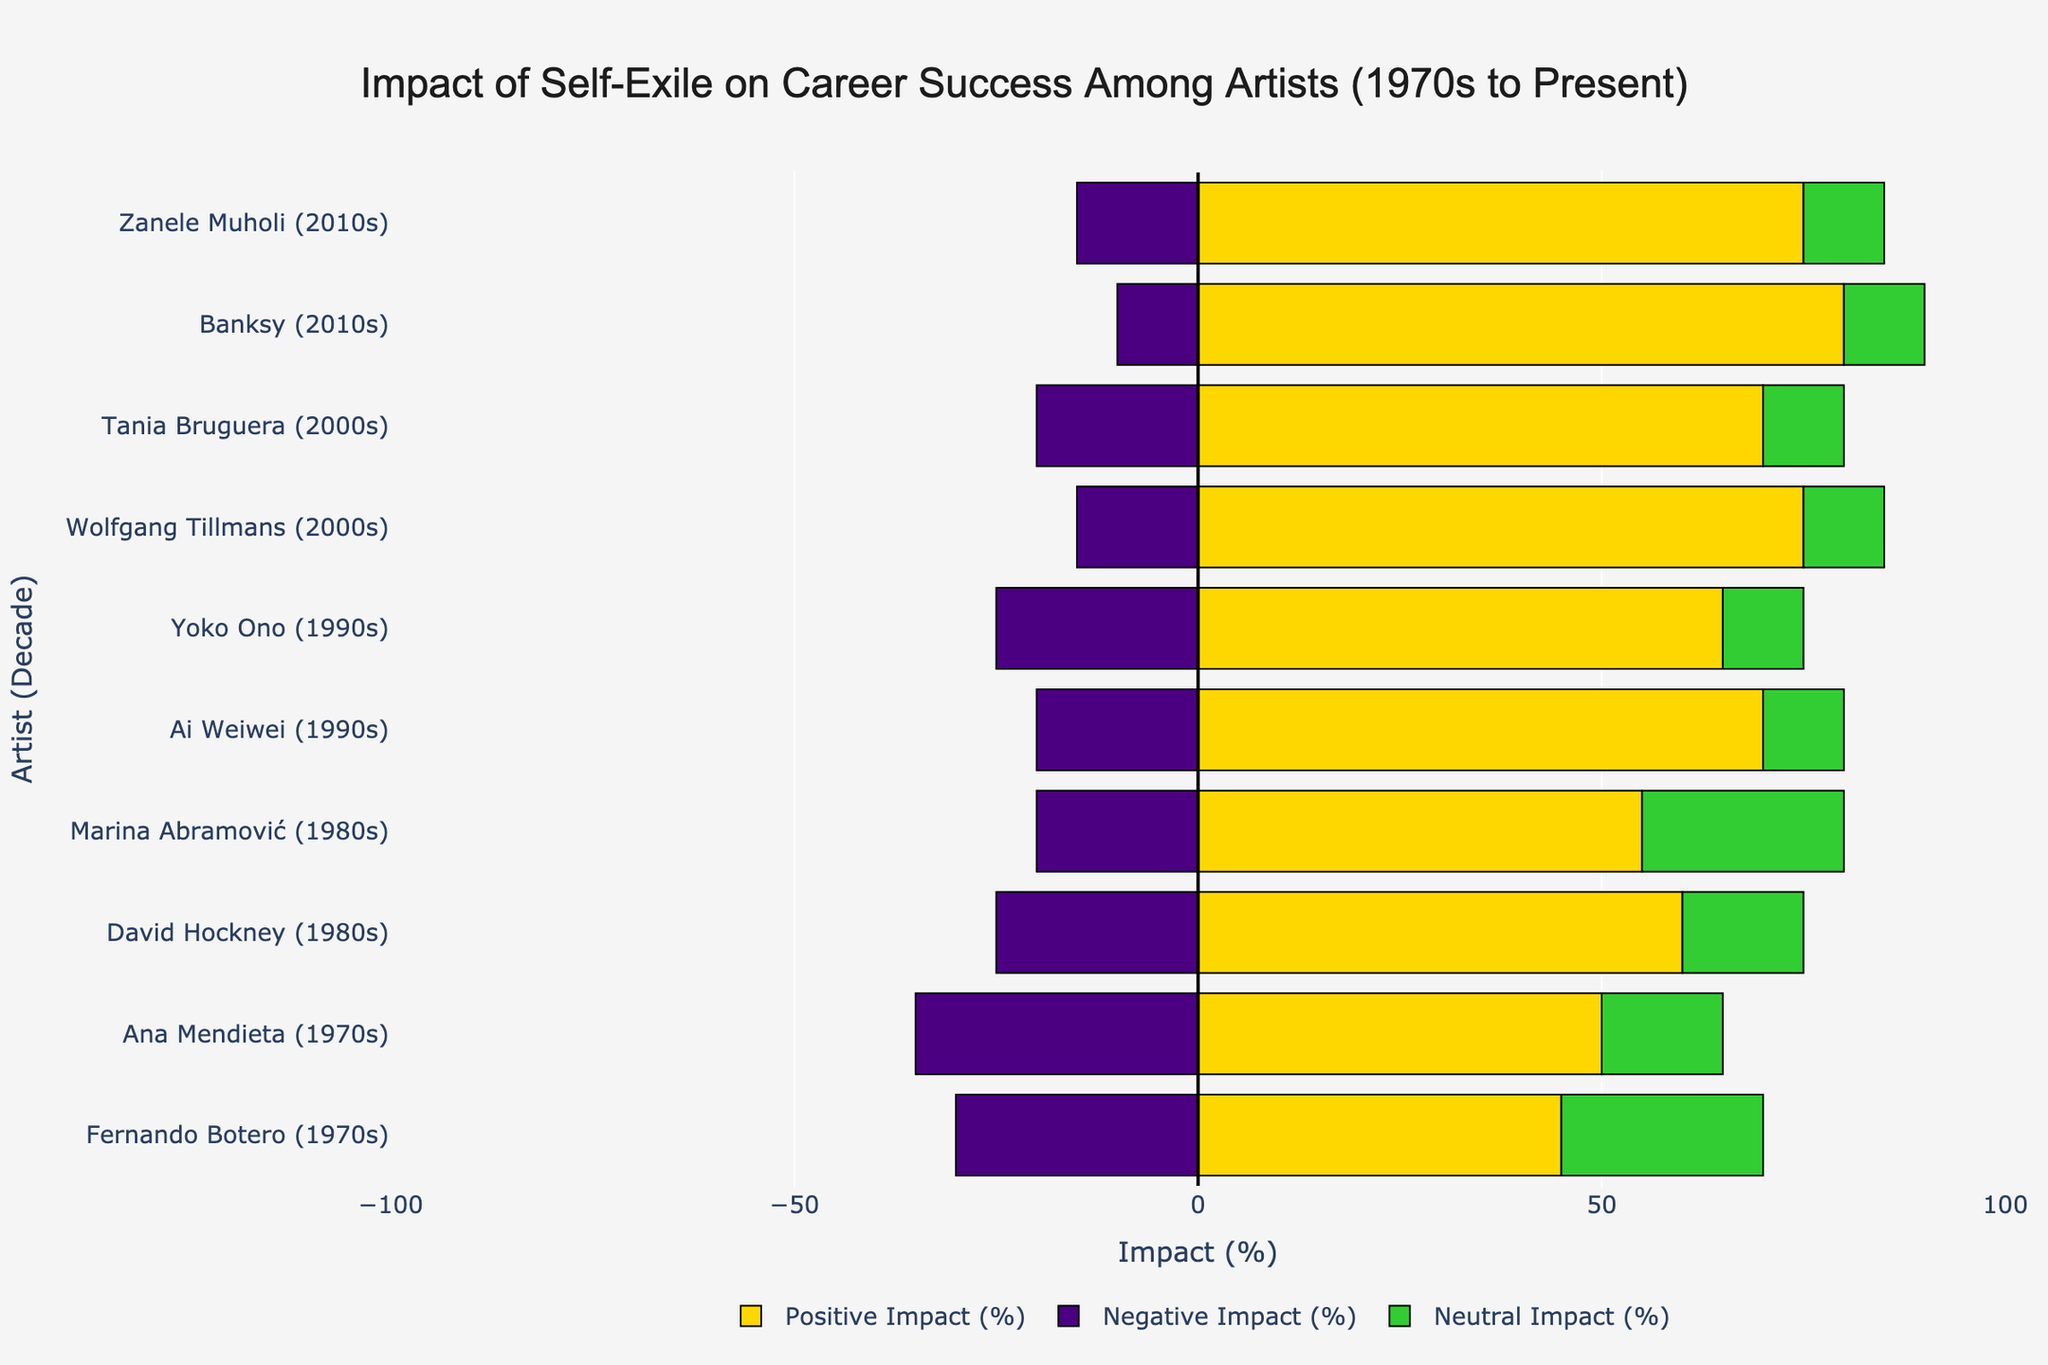How does the total positive impact on career success compare between artists of the 1970s and the 2000s? First, find the positive impact percentages for the 1970s (Fernando Botero: 45, Ana Mendieta: 50) and sum them: 45 + 50 = 95. For the 2000s (Wolfgang Tillmans: 75, Tania Bruguera: 70), sum them as well: 75 + 70 = 145. Therefore, the total positive impact for the 2000s (145) is greater than for the 1970s (95).
Answer: 2000s: 145, 1970s: 95 Which artist had the highest positive impact percentage, and in which decade? Refer to the figure and look for the highest value in the positive impact section. Banksy, in the 2010s, had the highest positive impact percentage at 80%.
Answer: Banksy, 2010s What is the combined neutral impact percentage for females in the 1980s? Identify the female artists from the 1980s (Marina Abramović) and sum the neutral impact values. Marina Abramović had a neutral impact of 25%.
Answer: 25% Which artist had the smallest negative impact, and in which decade? Look at the negative impact section to find the smallest negative value. Banksy in the 2010s had the smallest negative impact at 10%.
Answer: Banksy, 2010s Compare the neutral impact percentages between Ana Mendieta in the 1970s and Zanele Muholi in the 2010s. Ana Mendieta had a 15% neutral impact, and Zanele Muholi had a 10% neutral impact. Therefore, Ana Mendieta had a higher neutral impact than Zanele Muholi.
Answer: Ana Mendieta: 15%, Zanele Muholi: 10% 